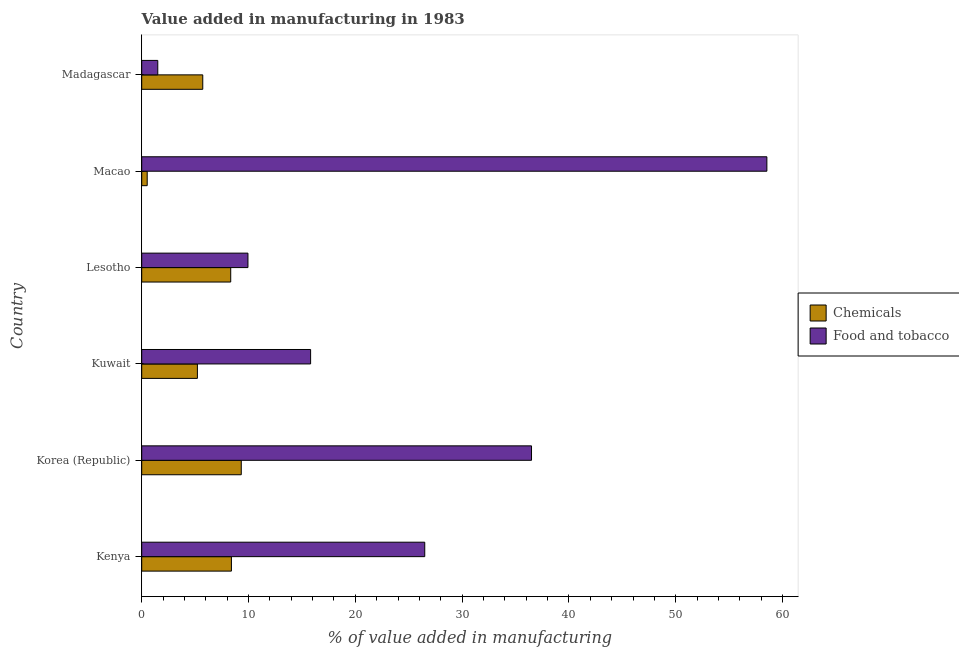Are the number of bars per tick equal to the number of legend labels?
Give a very brief answer. Yes. How many bars are there on the 5th tick from the bottom?
Your answer should be compact. 2. What is the label of the 3rd group of bars from the top?
Your response must be concise. Lesotho. In how many cases, is the number of bars for a given country not equal to the number of legend labels?
Give a very brief answer. 0. What is the value added by  manufacturing chemicals in Korea (Republic)?
Provide a short and direct response. 9.32. Across all countries, what is the maximum value added by  manufacturing chemicals?
Your answer should be compact. 9.32. Across all countries, what is the minimum value added by  manufacturing chemicals?
Provide a short and direct response. 0.51. In which country was the value added by manufacturing food and tobacco maximum?
Provide a succinct answer. Macao. In which country was the value added by  manufacturing chemicals minimum?
Give a very brief answer. Macao. What is the total value added by manufacturing food and tobacco in the graph?
Ensure brevity in your answer.  148.79. What is the difference between the value added by  manufacturing chemicals in Lesotho and that in Macao?
Provide a short and direct response. 7.82. What is the difference between the value added by manufacturing food and tobacco in Kenya and the value added by  manufacturing chemicals in Madagascar?
Give a very brief answer. 20.78. What is the average value added by  manufacturing chemicals per country?
Ensure brevity in your answer.  6.25. What is the difference between the value added by  manufacturing chemicals and value added by manufacturing food and tobacco in Kuwait?
Your answer should be compact. -10.6. What is the ratio of the value added by  manufacturing chemicals in Macao to that in Madagascar?
Your response must be concise. 0.09. Is the value added by manufacturing food and tobacco in Korea (Republic) less than that in Lesotho?
Make the answer very short. No. What is the difference between the highest and the second highest value added by  manufacturing chemicals?
Offer a very short reply. 0.92. What is the difference between the highest and the lowest value added by manufacturing food and tobacco?
Keep it short and to the point. 57.03. What does the 2nd bar from the top in Madagascar represents?
Offer a very short reply. Chemicals. What does the 1st bar from the bottom in Korea (Republic) represents?
Give a very brief answer. Chemicals. Are all the bars in the graph horizontal?
Offer a very short reply. Yes. How many countries are there in the graph?
Offer a very short reply. 6. What is the difference between two consecutive major ticks on the X-axis?
Keep it short and to the point. 10. Where does the legend appear in the graph?
Your answer should be compact. Center right. How many legend labels are there?
Provide a succinct answer. 2. What is the title of the graph?
Your answer should be compact. Value added in manufacturing in 1983. Does "Personal remittances" appear as one of the legend labels in the graph?
Give a very brief answer. No. What is the label or title of the X-axis?
Offer a terse response. % of value added in manufacturing. What is the label or title of the Y-axis?
Give a very brief answer. Country. What is the % of value added in manufacturing of Chemicals in Kenya?
Your answer should be very brief. 8.4. What is the % of value added in manufacturing of Food and tobacco in Kenya?
Provide a succinct answer. 26.5. What is the % of value added in manufacturing of Chemicals in Korea (Republic)?
Provide a short and direct response. 9.32. What is the % of value added in manufacturing in Food and tobacco in Korea (Republic)?
Offer a very short reply. 36.5. What is the % of value added in manufacturing in Chemicals in Kuwait?
Ensure brevity in your answer.  5.21. What is the % of value added in manufacturing of Food and tobacco in Kuwait?
Keep it short and to the point. 15.81. What is the % of value added in manufacturing in Chemicals in Lesotho?
Your answer should be compact. 8.33. What is the % of value added in manufacturing in Food and tobacco in Lesotho?
Ensure brevity in your answer.  9.95. What is the % of value added in manufacturing in Chemicals in Macao?
Provide a short and direct response. 0.51. What is the % of value added in manufacturing in Food and tobacco in Macao?
Your answer should be compact. 58.53. What is the % of value added in manufacturing of Chemicals in Madagascar?
Provide a short and direct response. 5.72. What is the % of value added in manufacturing of Food and tobacco in Madagascar?
Ensure brevity in your answer.  1.5. Across all countries, what is the maximum % of value added in manufacturing of Chemicals?
Provide a succinct answer. 9.32. Across all countries, what is the maximum % of value added in manufacturing in Food and tobacco?
Your answer should be compact. 58.53. Across all countries, what is the minimum % of value added in manufacturing of Chemicals?
Offer a very short reply. 0.51. Across all countries, what is the minimum % of value added in manufacturing in Food and tobacco?
Keep it short and to the point. 1.5. What is the total % of value added in manufacturing of Chemicals in the graph?
Offer a very short reply. 37.49. What is the total % of value added in manufacturing in Food and tobacco in the graph?
Offer a very short reply. 148.79. What is the difference between the % of value added in manufacturing in Chemicals in Kenya and that in Korea (Republic)?
Give a very brief answer. -0.92. What is the difference between the % of value added in manufacturing in Food and tobacco in Kenya and that in Korea (Republic)?
Provide a short and direct response. -10. What is the difference between the % of value added in manufacturing of Chemicals in Kenya and that in Kuwait?
Your answer should be very brief. 3.18. What is the difference between the % of value added in manufacturing of Food and tobacco in Kenya and that in Kuwait?
Your answer should be very brief. 10.69. What is the difference between the % of value added in manufacturing of Chemicals in Kenya and that in Lesotho?
Provide a short and direct response. 0.07. What is the difference between the % of value added in manufacturing of Food and tobacco in Kenya and that in Lesotho?
Offer a very short reply. 16.55. What is the difference between the % of value added in manufacturing of Chemicals in Kenya and that in Macao?
Offer a terse response. 7.89. What is the difference between the % of value added in manufacturing of Food and tobacco in Kenya and that in Macao?
Provide a succinct answer. -32.03. What is the difference between the % of value added in manufacturing in Chemicals in Kenya and that in Madagascar?
Keep it short and to the point. 2.68. What is the difference between the % of value added in manufacturing of Food and tobacco in Kenya and that in Madagascar?
Ensure brevity in your answer.  25. What is the difference between the % of value added in manufacturing of Chemicals in Korea (Republic) and that in Kuwait?
Ensure brevity in your answer.  4.11. What is the difference between the % of value added in manufacturing in Food and tobacco in Korea (Republic) and that in Kuwait?
Offer a terse response. 20.68. What is the difference between the % of value added in manufacturing in Food and tobacco in Korea (Republic) and that in Lesotho?
Offer a very short reply. 26.55. What is the difference between the % of value added in manufacturing of Chemicals in Korea (Republic) and that in Macao?
Give a very brief answer. 8.81. What is the difference between the % of value added in manufacturing of Food and tobacco in Korea (Republic) and that in Macao?
Your answer should be very brief. -22.03. What is the difference between the % of value added in manufacturing in Chemicals in Korea (Republic) and that in Madagascar?
Give a very brief answer. 3.6. What is the difference between the % of value added in manufacturing of Food and tobacco in Korea (Republic) and that in Madagascar?
Your answer should be very brief. 34.99. What is the difference between the % of value added in manufacturing of Chemicals in Kuwait and that in Lesotho?
Make the answer very short. -3.12. What is the difference between the % of value added in manufacturing of Food and tobacco in Kuwait and that in Lesotho?
Offer a very short reply. 5.87. What is the difference between the % of value added in manufacturing of Chemicals in Kuwait and that in Macao?
Keep it short and to the point. 4.7. What is the difference between the % of value added in manufacturing in Food and tobacco in Kuwait and that in Macao?
Your answer should be very brief. -42.72. What is the difference between the % of value added in manufacturing of Chemicals in Kuwait and that in Madagascar?
Your response must be concise. -0.5. What is the difference between the % of value added in manufacturing of Food and tobacco in Kuwait and that in Madagascar?
Your answer should be very brief. 14.31. What is the difference between the % of value added in manufacturing of Chemicals in Lesotho and that in Macao?
Make the answer very short. 7.82. What is the difference between the % of value added in manufacturing in Food and tobacco in Lesotho and that in Macao?
Your answer should be very brief. -48.58. What is the difference between the % of value added in manufacturing of Chemicals in Lesotho and that in Madagascar?
Keep it short and to the point. 2.62. What is the difference between the % of value added in manufacturing of Food and tobacco in Lesotho and that in Madagascar?
Your answer should be very brief. 8.44. What is the difference between the % of value added in manufacturing in Chemicals in Macao and that in Madagascar?
Ensure brevity in your answer.  -5.2. What is the difference between the % of value added in manufacturing in Food and tobacco in Macao and that in Madagascar?
Offer a very short reply. 57.03. What is the difference between the % of value added in manufacturing of Chemicals in Kenya and the % of value added in manufacturing of Food and tobacco in Korea (Republic)?
Ensure brevity in your answer.  -28.1. What is the difference between the % of value added in manufacturing in Chemicals in Kenya and the % of value added in manufacturing in Food and tobacco in Kuwait?
Your answer should be very brief. -7.41. What is the difference between the % of value added in manufacturing in Chemicals in Kenya and the % of value added in manufacturing in Food and tobacco in Lesotho?
Keep it short and to the point. -1.55. What is the difference between the % of value added in manufacturing in Chemicals in Kenya and the % of value added in manufacturing in Food and tobacco in Macao?
Make the answer very short. -50.13. What is the difference between the % of value added in manufacturing in Chemicals in Kenya and the % of value added in manufacturing in Food and tobacco in Madagascar?
Provide a short and direct response. 6.89. What is the difference between the % of value added in manufacturing of Chemicals in Korea (Republic) and the % of value added in manufacturing of Food and tobacco in Kuwait?
Offer a very short reply. -6.49. What is the difference between the % of value added in manufacturing in Chemicals in Korea (Republic) and the % of value added in manufacturing in Food and tobacco in Lesotho?
Provide a succinct answer. -0.63. What is the difference between the % of value added in manufacturing of Chemicals in Korea (Republic) and the % of value added in manufacturing of Food and tobacco in Macao?
Your response must be concise. -49.21. What is the difference between the % of value added in manufacturing of Chemicals in Korea (Republic) and the % of value added in manufacturing of Food and tobacco in Madagascar?
Your answer should be compact. 7.82. What is the difference between the % of value added in manufacturing in Chemicals in Kuwait and the % of value added in manufacturing in Food and tobacco in Lesotho?
Your answer should be compact. -4.73. What is the difference between the % of value added in manufacturing in Chemicals in Kuwait and the % of value added in manufacturing in Food and tobacco in Macao?
Offer a very short reply. -53.32. What is the difference between the % of value added in manufacturing in Chemicals in Kuwait and the % of value added in manufacturing in Food and tobacco in Madagascar?
Keep it short and to the point. 3.71. What is the difference between the % of value added in manufacturing of Chemicals in Lesotho and the % of value added in manufacturing of Food and tobacco in Macao?
Ensure brevity in your answer.  -50.2. What is the difference between the % of value added in manufacturing of Chemicals in Lesotho and the % of value added in manufacturing of Food and tobacco in Madagascar?
Provide a succinct answer. 6.83. What is the difference between the % of value added in manufacturing in Chemicals in Macao and the % of value added in manufacturing in Food and tobacco in Madagascar?
Ensure brevity in your answer.  -0.99. What is the average % of value added in manufacturing in Chemicals per country?
Your answer should be compact. 6.25. What is the average % of value added in manufacturing in Food and tobacco per country?
Make the answer very short. 24.8. What is the difference between the % of value added in manufacturing of Chemicals and % of value added in manufacturing of Food and tobacco in Kenya?
Make the answer very short. -18.1. What is the difference between the % of value added in manufacturing in Chemicals and % of value added in manufacturing in Food and tobacco in Korea (Republic)?
Offer a terse response. -27.18. What is the difference between the % of value added in manufacturing in Chemicals and % of value added in manufacturing in Food and tobacco in Kuwait?
Give a very brief answer. -10.6. What is the difference between the % of value added in manufacturing in Chemicals and % of value added in manufacturing in Food and tobacco in Lesotho?
Your answer should be compact. -1.61. What is the difference between the % of value added in manufacturing of Chemicals and % of value added in manufacturing of Food and tobacco in Macao?
Your response must be concise. -58.02. What is the difference between the % of value added in manufacturing of Chemicals and % of value added in manufacturing of Food and tobacco in Madagascar?
Provide a short and direct response. 4.21. What is the ratio of the % of value added in manufacturing in Chemicals in Kenya to that in Korea (Republic)?
Provide a succinct answer. 0.9. What is the ratio of the % of value added in manufacturing of Food and tobacco in Kenya to that in Korea (Republic)?
Give a very brief answer. 0.73. What is the ratio of the % of value added in manufacturing in Chemicals in Kenya to that in Kuwait?
Your response must be concise. 1.61. What is the ratio of the % of value added in manufacturing of Food and tobacco in Kenya to that in Kuwait?
Provide a succinct answer. 1.68. What is the ratio of the % of value added in manufacturing of Chemicals in Kenya to that in Lesotho?
Your answer should be compact. 1.01. What is the ratio of the % of value added in manufacturing of Food and tobacco in Kenya to that in Lesotho?
Your answer should be compact. 2.66. What is the ratio of the % of value added in manufacturing of Chemicals in Kenya to that in Macao?
Offer a very short reply. 16.39. What is the ratio of the % of value added in manufacturing in Food and tobacco in Kenya to that in Macao?
Ensure brevity in your answer.  0.45. What is the ratio of the % of value added in manufacturing of Chemicals in Kenya to that in Madagascar?
Provide a succinct answer. 1.47. What is the ratio of the % of value added in manufacturing of Food and tobacco in Kenya to that in Madagascar?
Your response must be concise. 17.63. What is the ratio of the % of value added in manufacturing in Chemicals in Korea (Republic) to that in Kuwait?
Your answer should be very brief. 1.79. What is the ratio of the % of value added in manufacturing of Food and tobacco in Korea (Republic) to that in Kuwait?
Keep it short and to the point. 2.31. What is the ratio of the % of value added in manufacturing of Chemicals in Korea (Republic) to that in Lesotho?
Provide a succinct answer. 1.12. What is the ratio of the % of value added in manufacturing in Food and tobacco in Korea (Republic) to that in Lesotho?
Keep it short and to the point. 3.67. What is the ratio of the % of value added in manufacturing in Chemicals in Korea (Republic) to that in Macao?
Provide a succinct answer. 18.18. What is the ratio of the % of value added in manufacturing of Food and tobacco in Korea (Republic) to that in Macao?
Ensure brevity in your answer.  0.62. What is the ratio of the % of value added in manufacturing in Chemicals in Korea (Republic) to that in Madagascar?
Ensure brevity in your answer.  1.63. What is the ratio of the % of value added in manufacturing of Food and tobacco in Korea (Republic) to that in Madagascar?
Offer a very short reply. 24.28. What is the ratio of the % of value added in manufacturing in Chemicals in Kuwait to that in Lesotho?
Offer a very short reply. 0.63. What is the ratio of the % of value added in manufacturing of Food and tobacco in Kuwait to that in Lesotho?
Offer a terse response. 1.59. What is the ratio of the % of value added in manufacturing of Chemicals in Kuwait to that in Macao?
Your answer should be very brief. 10.17. What is the ratio of the % of value added in manufacturing in Food and tobacco in Kuwait to that in Macao?
Ensure brevity in your answer.  0.27. What is the ratio of the % of value added in manufacturing of Chemicals in Kuwait to that in Madagascar?
Make the answer very short. 0.91. What is the ratio of the % of value added in manufacturing in Food and tobacco in Kuwait to that in Madagascar?
Give a very brief answer. 10.52. What is the ratio of the % of value added in manufacturing in Chemicals in Lesotho to that in Macao?
Give a very brief answer. 16.26. What is the ratio of the % of value added in manufacturing of Food and tobacco in Lesotho to that in Macao?
Provide a succinct answer. 0.17. What is the ratio of the % of value added in manufacturing of Chemicals in Lesotho to that in Madagascar?
Your response must be concise. 1.46. What is the ratio of the % of value added in manufacturing in Food and tobacco in Lesotho to that in Madagascar?
Make the answer very short. 6.62. What is the ratio of the % of value added in manufacturing of Chemicals in Macao to that in Madagascar?
Your answer should be very brief. 0.09. What is the ratio of the % of value added in manufacturing in Food and tobacco in Macao to that in Madagascar?
Provide a succinct answer. 38.93. What is the difference between the highest and the second highest % of value added in manufacturing of Chemicals?
Ensure brevity in your answer.  0.92. What is the difference between the highest and the second highest % of value added in manufacturing of Food and tobacco?
Provide a succinct answer. 22.03. What is the difference between the highest and the lowest % of value added in manufacturing of Chemicals?
Provide a succinct answer. 8.81. What is the difference between the highest and the lowest % of value added in manufacturing in Food and tobacco?
Give a very brief answer. 57.03. 